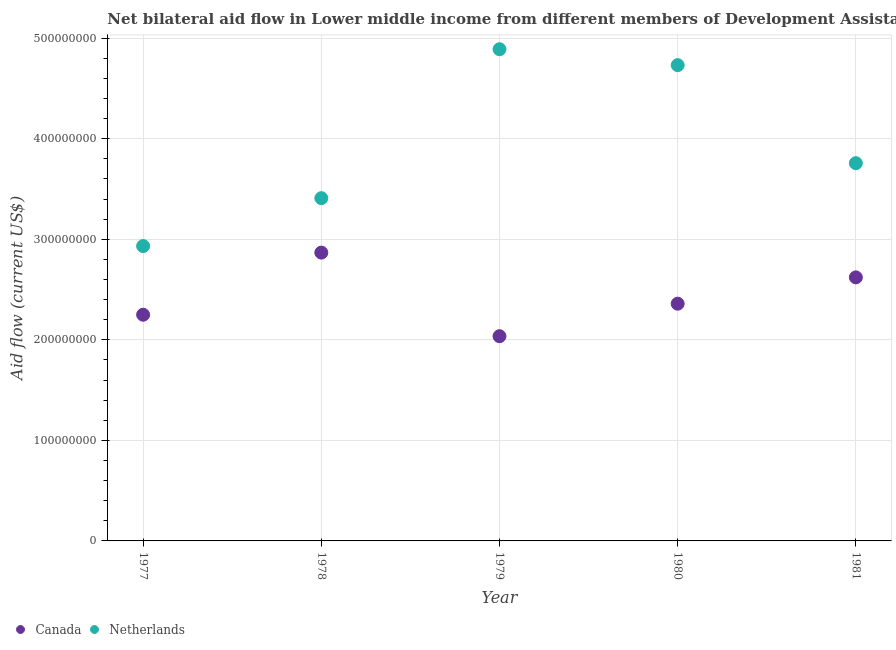What is the amount of aid given by canada in 1979?
Ensure brevity in your answer.  2.04e+08. Across all years, what is the maximum amount of aid given by netherlands?
Offer a very short reply. 4.89e+08. Across all years, what is the minimum amount of aid given by netherlands?
Ensure brevity in your answer.  2.93e+08. In which year was the amount of aid given by canada maximum?
Provide a short and direct response. 1978. In which year was the amount of aid given by canada minimum?
Offer a terse response. 1979. What is the total amount of aid given by canada in the graph?
Your answer should be very brief. 1.21e+09. What is the difference between the amount of aid given by canada in 1978 and that in 1979?
Your response must be concise. 8.31e+07. What is the difference between the amount of aid given by canada in 1978 and the amount of aid given by netherlands in 1977?
Keep it short and to the point. -6.51e+06. What is the average amount of aid given by canada per year?
Offer a very short reply. 2.43e+08. In the year 1979, what is the difference between the amount of aid given by netherlands and amount of aid given by canada?
Provide a succinct answer. 2.85e+08. In how many years, is the amount of aid given by netherlands greater than 140000000 US$?
Make the answer very short. 5. What is the ratio of the amount of aid given by canada in 1978 to that in 1980?
Make the answer very short. 1.22. Is the difference between the amount of aid given by netherlands in 1978 and 1979 greater than the difference between the amount of aid given by canada in 1978 and 1979?
Ensure brevity in your answer.  No. What is the difference between the highest and the second highest amount of aid given by netherlands?
Keep it short and to the point. 1.58e+07. What is the difference between the highest and the lowest amount of aid given by canada?
Offer a very short reply. 8.31e+07. Is the sum of the amount of aid given by canada in 1977 and 1981 greater than the maximum amount of aid given by netherlands across all years?
Your response must be concise. No. Does the amount of aid given by canada monotonically increase over the years?
Your answer should be compact. No. Is the amount of aid given by netherlands strictly greater than the amount of aid given by canada over the years?
Keep it short and to the point. Yes. Is the amount of aid given by canada strictly less than the amount of aid given by netherlands over the years?
Provide a succinct answer. Yes. How many dotlines are there?
Offer a terse response. 2. Does the graph contain any zero values?
Offer a terse response. No. What is the title of the graph?
Make the answer very short. Net bilateral aid flow in Lower middle income from different members of Development Assistance Committee. What is the label or title of the Y-axis?
Offer a very short reply. Aid flow (current US$). What is the Aid flow (current US$) of Canada in 1977?
Your answer should be very brief. 2.25e+08. What is the Aid flow (current US$) of Netherlands in 1977?
Make the answer very short. 2.93e+08. What is the Aid flow (current US$) in Canada in 1978?
Your answer should be very brief. 2.87e+08. What is the Aid flow (current US$) in Netherlands in 1978?
Offer a very short reply. 3.41e+08. What is the Aid flow (current US$) in Canada in 1979?
Keep it short and to the point. 2.04e+08. What is the Aid flow (current US$) in Netherlands in 1979?
Your answer should be compact. 4.89e+08. What is the Aid flow (current US$) in Canada in 1980?
Provide a short and direct response. 2.36e+08. What is the Aid flow (current US$) of Netherlands in 1980?
Provide a short and direct response. 4.73e+08. What is the Aid flow (current US$) of Canada in 1981?
Your response must be concise. 2.62e+08. What is the Aid flow (current US$) in Netherlands in 1981?
Give a very brief answer. 3.76e+08. Across all years, what is the maximum Aid flow (current US$) of Canada?
Provide a succinct answer. 2.87e+08. Across all years, what is the maximum Aid flow (current US$) of Netherlands?
Provide a succinct answer. 4.89e+08. Across all years, what is the minimum Aid flow (current US$) in Canada?
Provide a short and direct response. 2.04e+08. Across all years, what is the minimum Aid flow (current US$) in Netherlands?
Ensure brevity in your answer.  2.93e+08. What is the total Aid flow (current US$) in Canada in the graph?
Give a very brief answer. 1.21e+09. What is the total Aid flow (current US$) of Netherlands in the graph?
Your answer should be very brief. 1.97e+09. What is the difference between the Aid flow (current US$) in Canada in 1977 and that in 1978?
Provide a succinct answer. -6.18e+07. What is the difference between the Aid flow (current US$) in Netherlands in 1977 and that in 1978?
Offer a very short reply. -4.76e+07. What is the difference between the Aid flow (current US$) in Canada in 1977 and that in 1979?
Provide a short and direct response. 2.14e+07. What is the difference between the Aid flow (current US$) in Netherlands in 1977 and that in 1979?
Offer a very short reply. -1.96e+08. What is the difference between the Aid flow (current US$) of Canada in 1977 and that in 1980?
Ensure brevity in your answer.  -1.10e+07. What is the difference between the Aid flow (current US$) in Netherlands in 1977 and that in 1980?
Make the answer very short. -1.80e+08. What is the difference between the Aid flow (current US$) of Canada in 1977 and that in 1981?
Your answer should be very brief. -3.71e+07. What is the difference between the Aid flow (current US$) of Netherlands in 1977 and that in 1981?
Offer a very short reply. -8.24e+07. What is the difference between the Aid flow (current US$) of Canada in 1978 and that in 1979?
Your answer should be very brief. 8.31e+07. What is the difference between the Aid flow (current US$) of Netherlands in 1978 and that in 1979?
Provide a short and direct response. -1.48e+08. What is the difference between the Aid flow (current US$) in Canada in 1978 and that in 1980?
Provide a short and direct response. 5.08e+07. What is the difference between the Aid flow (current US$) of Netherlands in 1978 and that in 1980?
Your answer should be very brief. -1.32e+08. What is the difference between the Aid flow (current US$) in Canada in 1978 and that in 1981?
Your answer should be compact. 2.46e+07. What is the difference between the Aid flow (current US$) in Netherlands in 1978 and that in 1981?
Offer a terse response. -3.48e+07. What is the difference between the Aid flow (current US$) of Canada in 1979 and that in 1980?
Your answer should be very brief. -3.23e+07. What is the difference between the Aid flow (current US$) in Netherlands in 1979 and that in 1980?
Provide a short and direct response. 1.58e+07. What is the difference between the Aid flow (current US$) of Canada in 1979 and that in 1981?
Give a very brief answer. -5.85e+07. What is the difference between the Aid flow (current US$) of Netherlands in 1979 and that in 1981?
Keep it short and to the point. 1.13e+08. What is the difference between the Aid flow (current US$) of Canada in 1980 and that in 1981?
Provide a short and direct response. -2.62e+07. What is the difference between the Aid flow (current US$) of Netherlands in 1980 and that in 1981?
Offer a very short reply. 9.75e+07. What is the difference between the Aid flow (current US$) of Canada in 1977 and the Aid flow (current US$) of Netherlands in 1978?
Your response must be concise. -1.16e+08. What is the difference between the Aid flow (current US$) of Canada in 1977 and the Aid flow (current US$) of Netherlands in 1979?
Ensure brevity in your answer.  -2.64e+08. What is the difference between the Aid flow (current US$) of Canada in 1977 and the Aid flow (current US$) of Netherlands in 1980?
Provide a short and direct response. -2.48e+08. What is the difference between the Aid flow (current US$) of Canada in 1977 and the Aid flow (current US$) of Netherlands in 1981?
Make the answer very short. -1.51e+08. What is the difference between the Aid flow (current US$) of Canada in 1978 and the Aid flow (current US$) of Netherlands in 1979?
Your response must be concise. -2.02e+08. What is the difference between the Aid flow (current US$) in Canada in 1978 and the Aid flow (current US$) in Netherlands in 1980?
Provide a succinct answer. -1.86e+08. What is the difference between the Aid flow (current US$) of Canada in 1978 and the Aid flow (current US$) of Netherlands in 1981?
Keep it short and to the point. -8.89e+07. What is the difference between the Aid flow (current US$) of Canada in 1979 and the Aid flow (current US$) of Netherlands in 1980?
Provide a short and direct response. -2.70e+08. What is the difference between the Aid flow (current US$) of Canada in 1979 and the Aid flow (current US$) of Netherlands in 1981?
Your answer should be compact. -1.72e+08. What is the difference between the Aid flow (current US$) of Canada in 1980 and the Aid flow (current US$) of Netherlands in 1981?
Make the answer very short. -1.40e+08. What is the average Aid flow (current US$) in Canada per year?
Offer a very short reply. 2.43e+08. What is the average Aid flow (current US$) of Netherlands per year?
Offer a terse response. 3.94e+08. In the year 1977, what is the difference between the Aid flow (current US$) of Canada and Aid flow (current US$) of Netherlands?
Provide a short and direct response. -6.83e+07. In the year 1978, what is the difference between the Aid flow (current US$) in Canada and Aid flow (current US$) in Netherlands?
Your answer should be very brief. -5.41e+07. In the year 1979, what is the difference between the Aid flow (current US$) of Canada and Aid flow (current US$) of Netherlands?
Offer a terse response. -2.85e+08. In the year 1980, what is the difference between the Aid flow (current US$) in Canada and Aid flow (current US$) in Netherlands?
Keep it short and to the point. -2.37e+08. In the year 1981, what is the difference between the Aid flow (current US$) in Canada and Aid flow (current US$) in Netherlands?
Your answer should be very brief. -1.14e+08. What is the ratio of the Aid flow (current US$) in Canada in 1977 to that in 1978?
Make the answer very short. 0.78. What is the ratio of the Aid flow (current US$) in Netherlands in 1977 to that in 1978?
Offer a very short reply. 0.86. What is the ratio of the Aid flow (current US$) of Canada in 1977 to that in 1979?
Your answer should be compact. 1.1. What is the ratio of the Aid flow (current US$) of Netherlands in 1977 to that in 1979?
Your answer should be very brief. 0.6. What is the ratio of the Aid flow (current US$) of Canada in 1977 to that in 1980?
Offer a terse response. 0.95. What is the ratio of the Aid flow (current US$) in Netherlands in 1977 to that in 1980?
Offer a very short reply. 0.62. What is the ratio of the Aid flow (current US$) in Canada in 1977 to that in 1981?
Keep it short and to the point. 0.86. What is the ratio of the Aid flow (current US$) of Netherlands in 1977 to that in 1981?
Provide a succinct answer. 0.78. What is the ratio of the Aid flow (current US$) of Canada in 1978 to that in 1979?
Keep it short and to the point. 1.41. What is the ratio of the Aid flow (current US$) of Netherlands in 1978 to that in 1979?
Offer a very short reply. 0.7. What is the ratio of the Aid flow (current US$) of Canada in 1978 to that in 1980?
Give a very brief answer. 1.22. What is the ratio of the Aid flow (current US$) in Netherlands in 1978 to that in 1980?
Your response must be concise. 0.72. What is the ratio of the Aid flow (current US$) of Canada in 1978 to that in 1981?
Provide a succinct answer. 1.09. What is the ratio of the Aid flow (current US$) in Netherlands in 1978 to that in 1981?
Keep it short and to the point. 0.91. What is the ratio of the Aid flow (current US$) of Canada in 1979 to that in 1980?
Offer a terse response. 0.86. What is the ratio of the Aid flow (current US$) in Netherlands in 1979 to that in 1980?
Provide a short and direct response. 1.03. What is the ratio of the Aid flow (current US$) of Canada in 1979 to that in 1981?
Your answer should be compact. 0.78. What is the ratio of the Aid flow (current US$) of Netherlands in 1979 to that in 1981?
Give a very brief answer. 1.3. What is the ratio of the Aid flow (current US$) in Canada in 1980 to that in 1981?
Offer a terse response. 0.9. What is the ratio of the Aid flow (current US$) of Netherlands in 1980 to that in 1981?
Offer a very short reply. 1.26. What is the difference between the highest and the second highest Aid flow (current US$) of Canada?
Provide a succinct answer. 2.46e+07. What is the difference between the highest and the second highest Aid flow (current US$) in Netherlands?
Your response must be concise. 1.58e+07. What is the difference between the highest and the lowest Aid flow (current US$) in Canada?
Make the answer very short. 8.31e+07. What is the difference between the highest and the lowest Aid flow (current US$) of Netherlands?
Your response must be concise. 1.96e+08. 